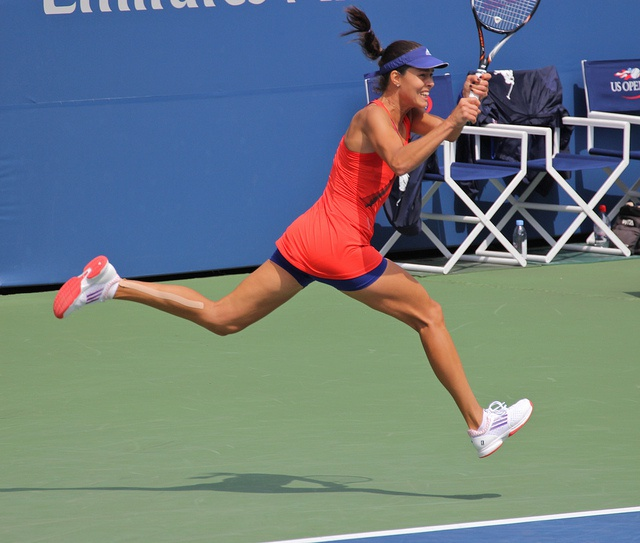Describe the objects in this image and their specific colors. I can see people in blue, salmon, brown, and red tones, chair in blue, black, navy, lightgray, and gray tones, chair in blue, black, lightgray, gray, and darkgray tones, chair in blue, navy, darkblue, and black tones, and tennis racket in blue, gray, darkgray, and black tones in this image. 